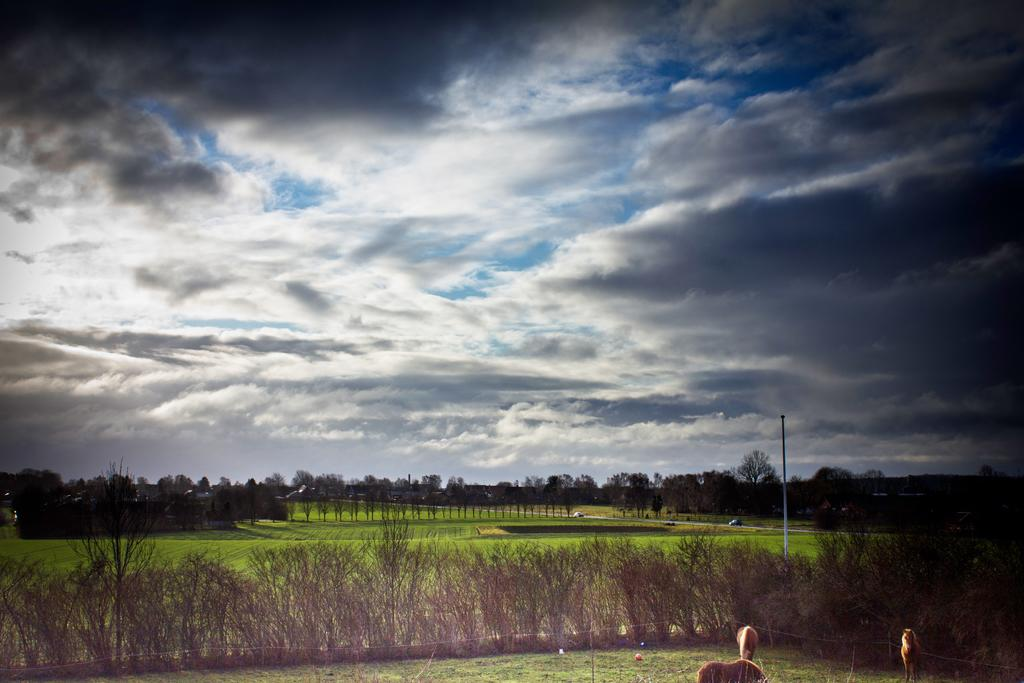What type of living organisms can be seen in the bottom right corner of the image? There are animals in the bottom right corner of the image. What else can be seen in the image besides the animals? There are plants in the image. What is visible in the background of the image? There are many trees and clouds in the background of the image. What part of the natural environment is visible in the image? The sky is visible in the background of the image. How does the image expand to show more details about the animals? The image does not expand; it is a static representation of the scene. Can you tell me what the animals are talking about in the image? There is no indication of the animals talking in the image, as it is a still image and does not depict any sounds or conversations. 